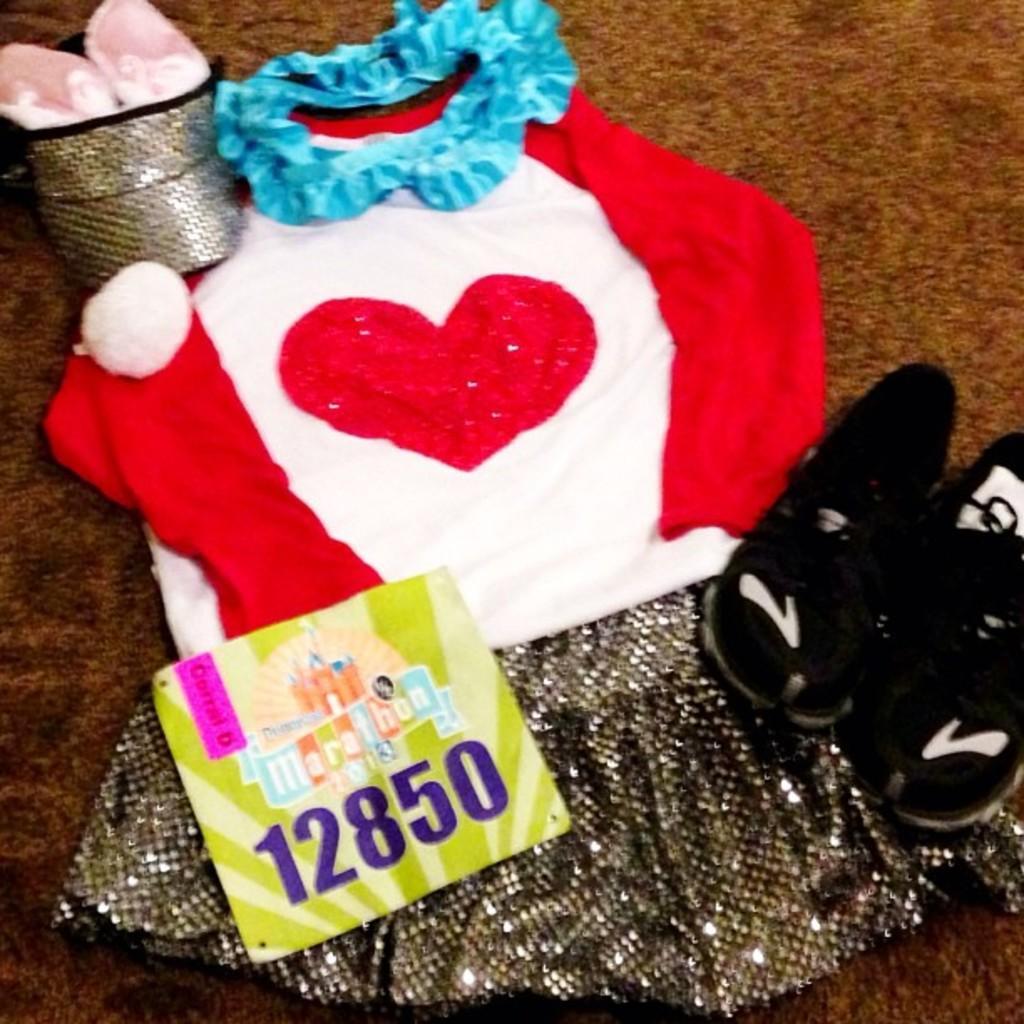Describe this image in one or two sentences. In the picture there is a dress and shoes kept on a carpet and there is some card kept above the dress. 